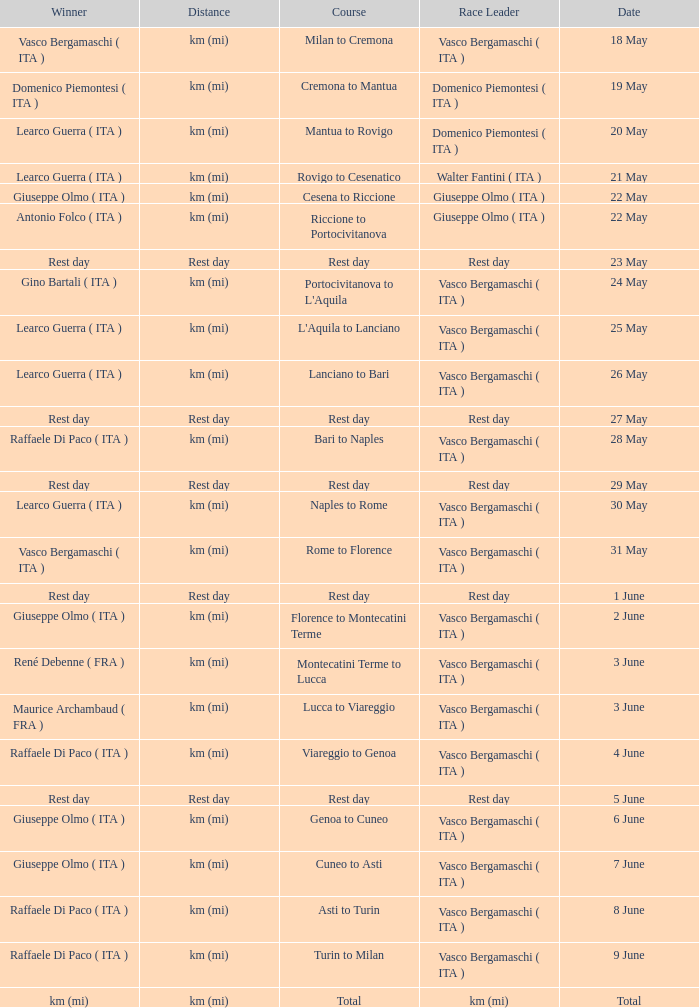Who won on 28 May? Raffaele Di Paco ( ITA ). 